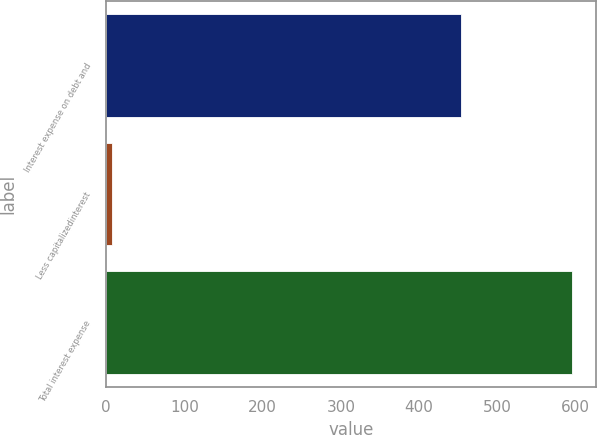Convert chart to OTSL. <chart><loc_0><loc_0><loc_500><loc_500><bar_chart><fcel>Interest expense on debt and<fcel>Less capitalizedinterest<fcel>Total interest expense<nl><fcel>453.5<fcel>7.8<fcel>595.9<nl></chart> 